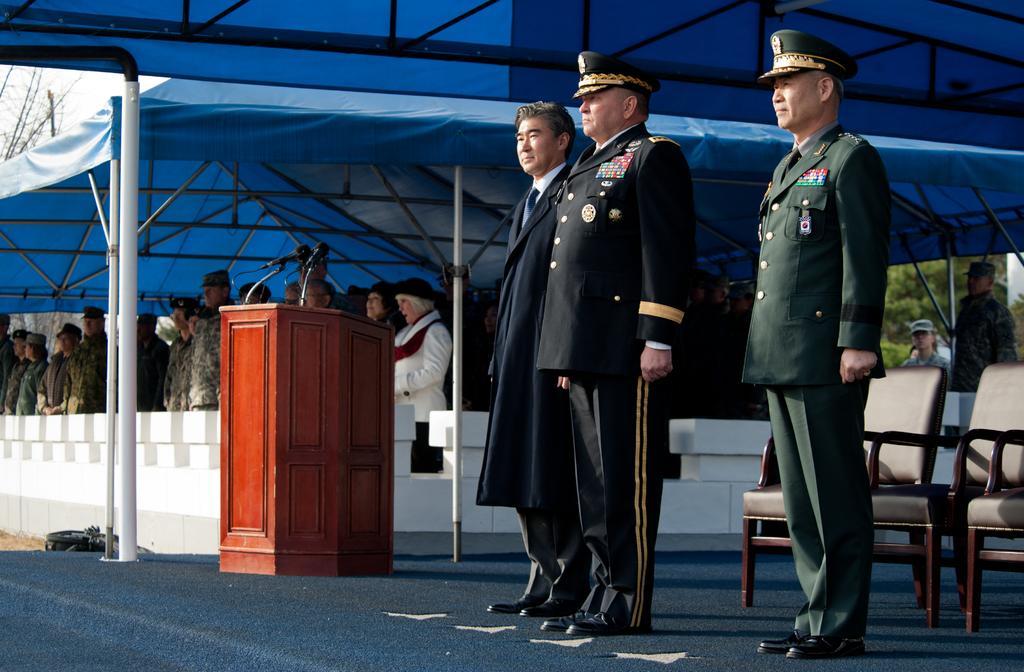Could you give a brief overview of what you see in this image? In this image in front there are three persons standing on the stage. Behind them there are chairs. Beside them there is a table. On the backside there are people standing under the tent. In the background there are trees. 